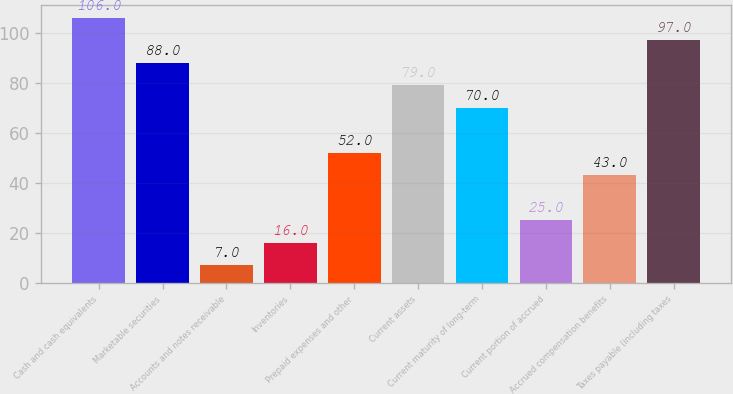<chart> <loc_0><loc_0><loc_500><loc_500><bar_chart><fcel>Cash and cash equivalents<fcel>Marketable securities<fcel>Accounts and notes receivable<fcel>Inventories<fcel>Prepaid expenses and other<fcel>Current assets<fcel>Current maturity of long-term<fcel>Current portion of accrued<fcel>Accrued compensation benefits<fcel>Taxes payable (including taxes<nl><fcel>106<fcel>88<fcel>7<fcel>16<fcel>52<fcel>79<fcel>70<fcel>25<fcel>43<fcel>97<nl></chart> 